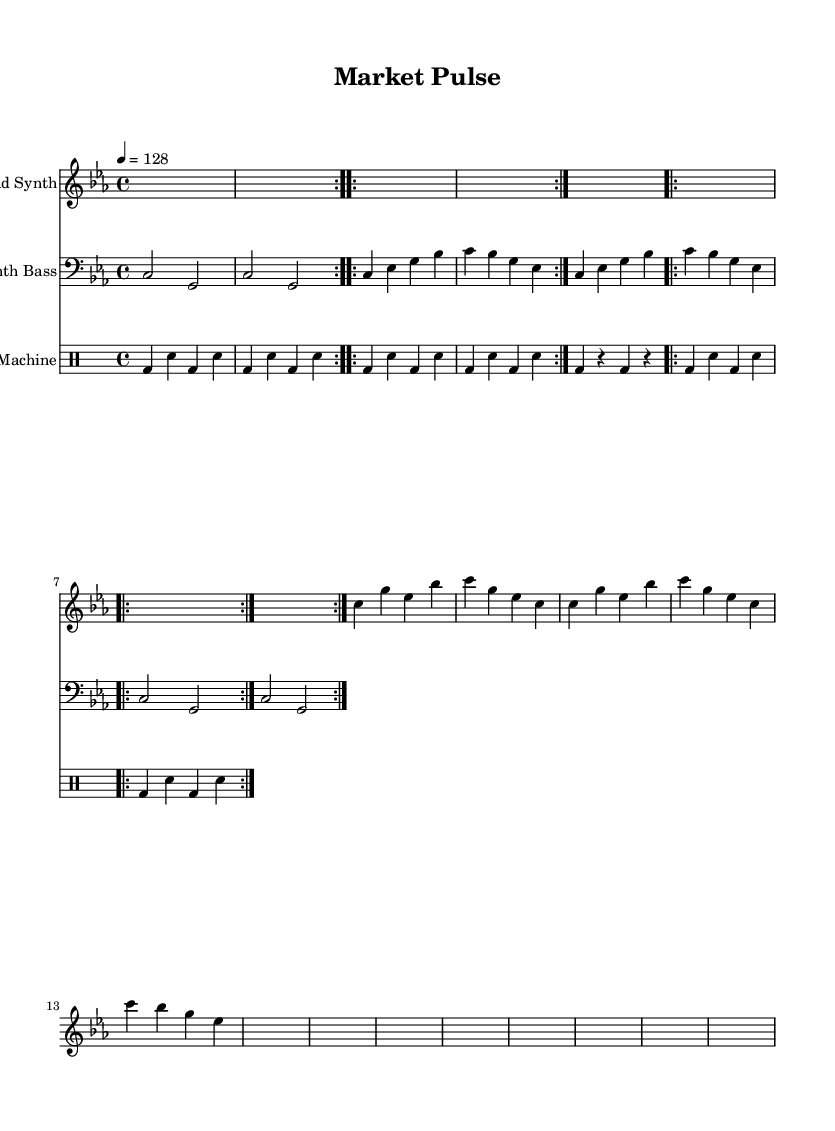What is the key signature of this music? The key signature indicates that the piece is in C minor, which has three flats (B-flat, E-flat, and A-flat). This can be deduced from the key signature notation in the music.
Answer: C minor What is the time signature of the piece? The time signature is found at the beginning of the score and shows a '4/4' value, meaning there are four beats in each measure, and the quarter note gets one beat.
Answer: 4/4 What is the tempo marking for the piece? The tempo marking states that the piece should be played at a speed of 128 beats per minute, indicated by the notation '4 = 128' at the beginning of the score.
Answer: 128 How many times is the synth bass motif repeated? The synth bass motif is written as rounded sections indicating it is repeated two times, specifically noted as '\repeat volta 2'.
Answer: 2 What instrument plays the lead synth? The lead synth is played by the staff labeled "Lead Synth" which is specified in the score layout.
Answer: Lead Synth Which percussion instrument is featured prominently in the drum machine section? The drum machine section prominently features the bass drum, as indicated by the regular appearances of 'bd' in the drum notation, which represents the bass drum sound.
Answer: Bass drum What rhythmic pattern is used in the drum machine section? The drum machine uses a consistent alternating pattern of bass drum and snare drum, which can be identified by the sequence of 'bd' and 'sn' notations repeated in the score.
Answer: Alternating bass and snare pattern 